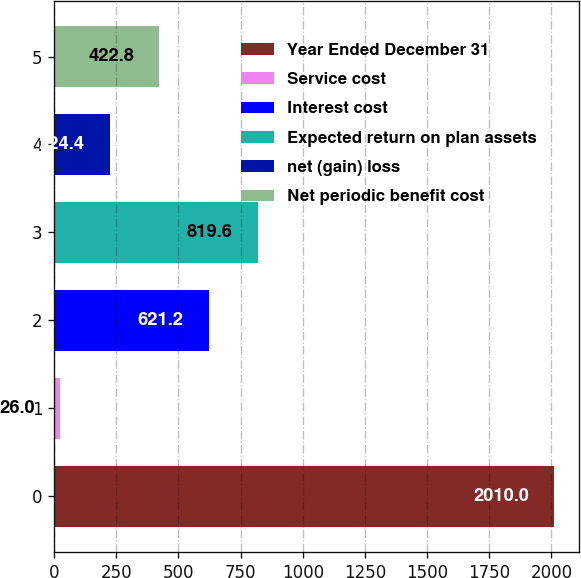<chart> <loc_0><loc_0><loc_500><loc_500><bar_chart><fcel>Year Ended December 31<fcel>Service cost<fcel>Interest cost<fcel>Expected return on plan assets<fcel>net (gain) loss<fcel>Net periodic benefit cost<nl><fcel>2010<fcel>26<fcel>621.2<fcel>819.6<fcel>224.4<fcel>422.8<nl></chart> 